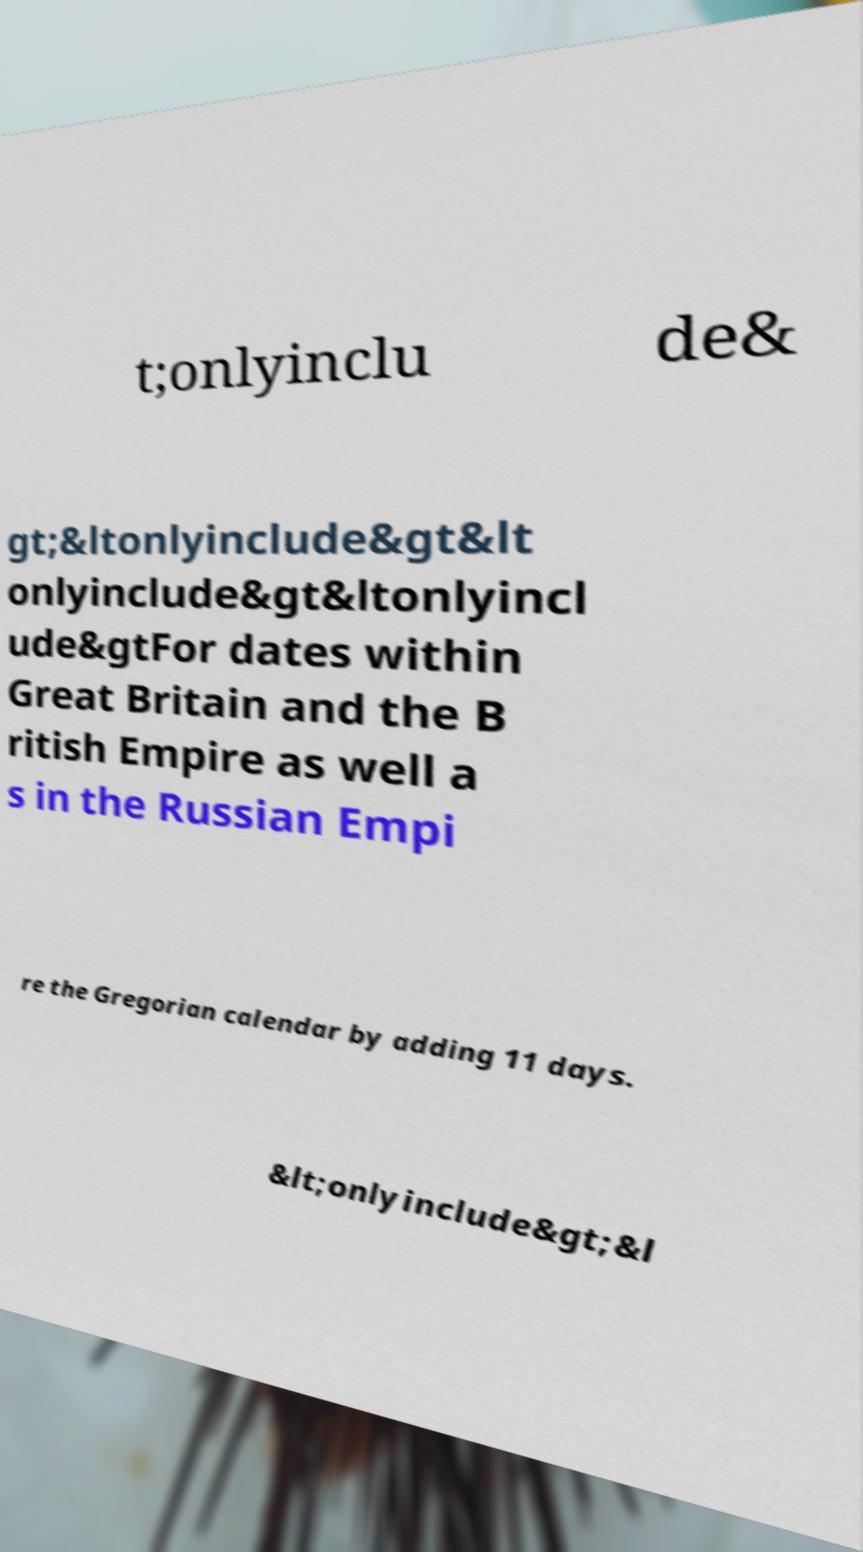Please identify and transcribe the text found in this image. t;onlyinclu de& gt;&ltonlyinclude&gt&lt onlyinclude&gt&ltonlyincl ude&gtFor dates within Great Britain and the B ritish Empire as well a s in the Russian Empi re the Gregorian calendar by adding 11 days. &lt;onlyinclude&gt;&l 